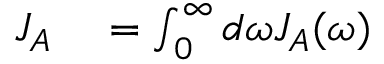Convert formula to latex. <formula><loc_0><loc_0><loc_500><loc_500>\begin{array} { r l } { J _ { A } } & = \int _ { 0 } ^ { \infty } d \omega J _ { A } ( \omega ) } \end{array}</formula> 